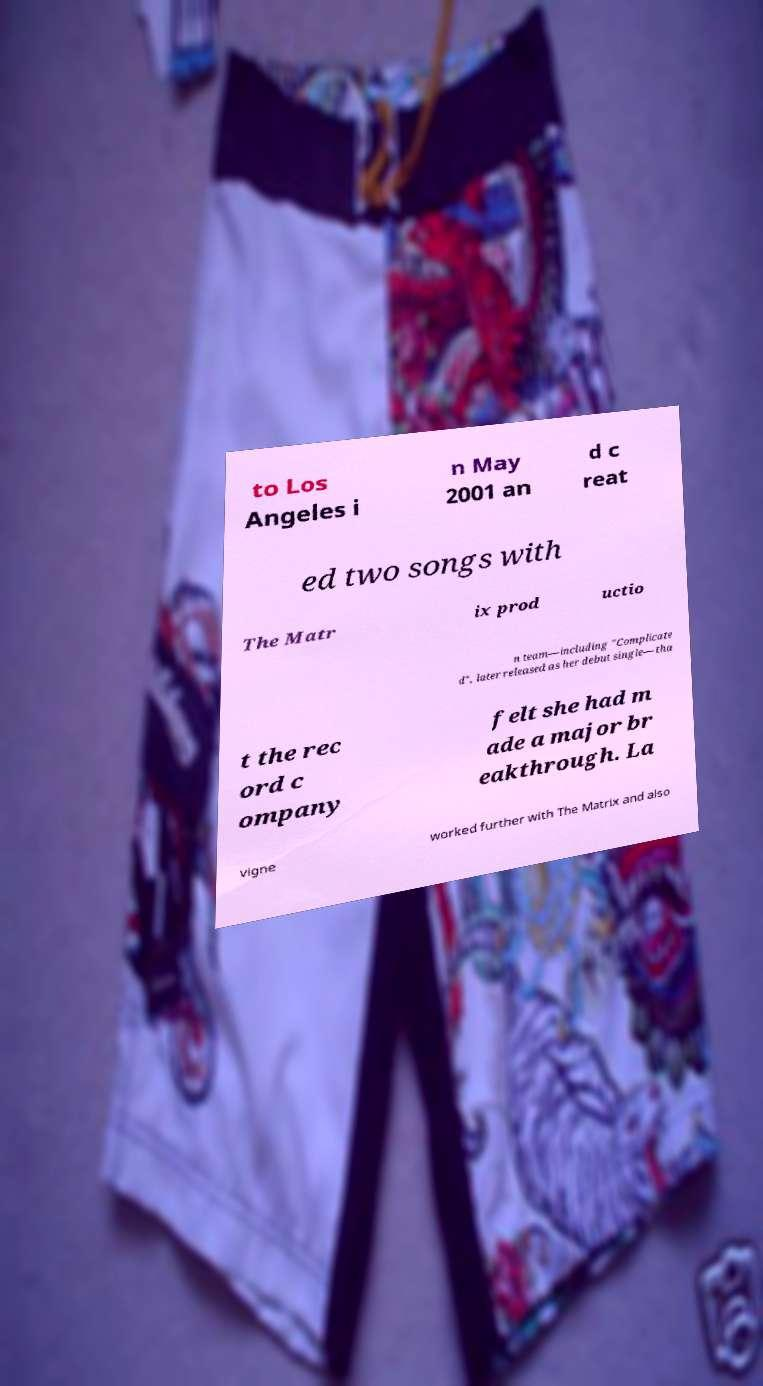Can you accurately transcribe the text from the provided image for me? to Los Angeles i n May 2001 an d c reat ed two songs with The Matr ix prod uctio n team—including "Complicate d", later released as her debut single—tha t the rec ord c ompany felt she had m ade a major br eakthrough. La vigne worked further with The Matrix and also 